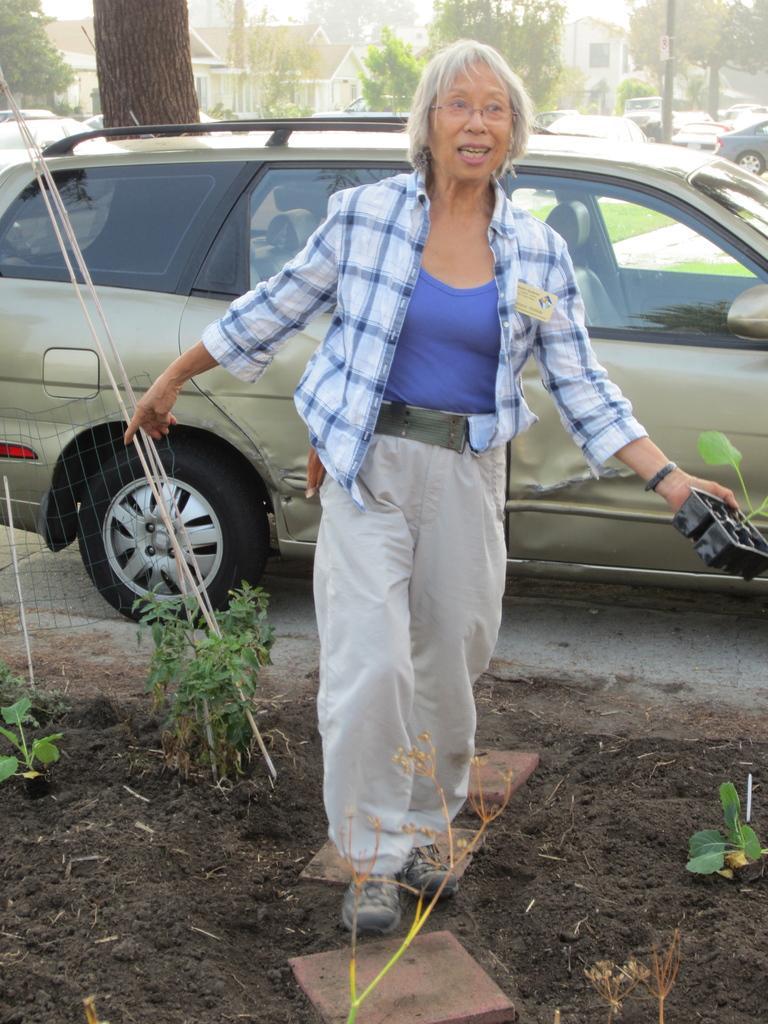How would you summarize this image in a sentence or two? This image is taken outdoors. At the bottom of the image there is a ground with a few plants on it. In the background there are a few trees and there are a few houses. Many cars are parked on the road. In the middle of the image a woman is walking on the ground and she is holding an object in her hand. 